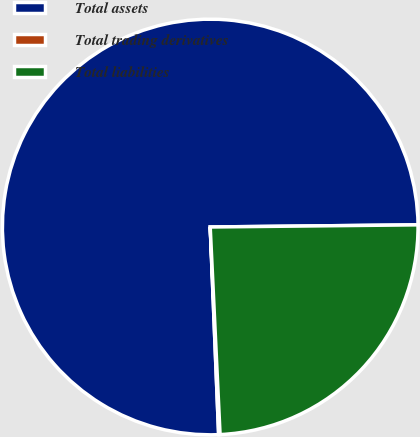Convert chart to OTSL. <chart><loc_0><loc_0><loc_500><loc_500><pie_chart><fcel>Total assets<fcel>Total trading derivatives<fcel>Total liabilities<nl><fcel>75.48%<fcel>0.11%<fcel>24.41%<nl></chart> 